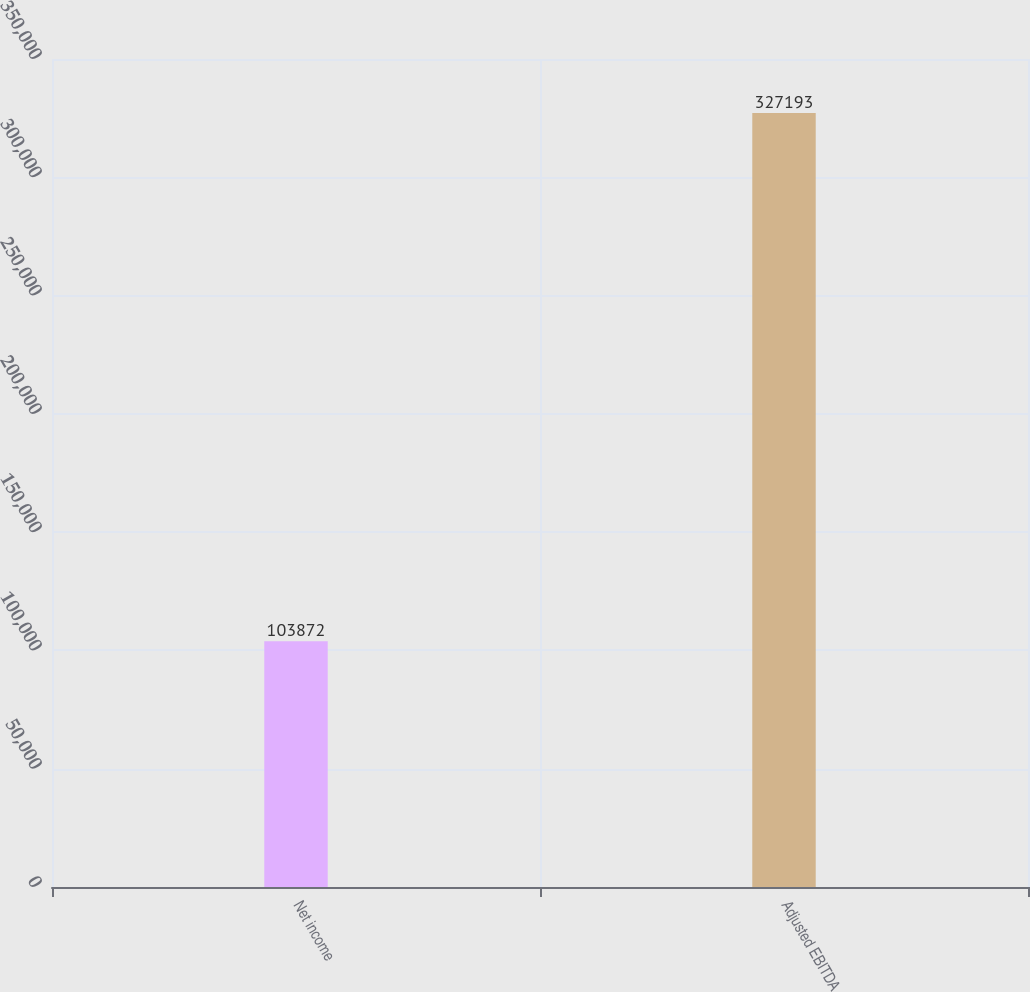Convert chart to OTSL. <chart><loc_0><loc_0><loc_500><loc_500><bar_chart><fcel>Net income<fcel>Adjusted EBITDA<nl><fcel>103872<fcel>327193<nl></chart> 